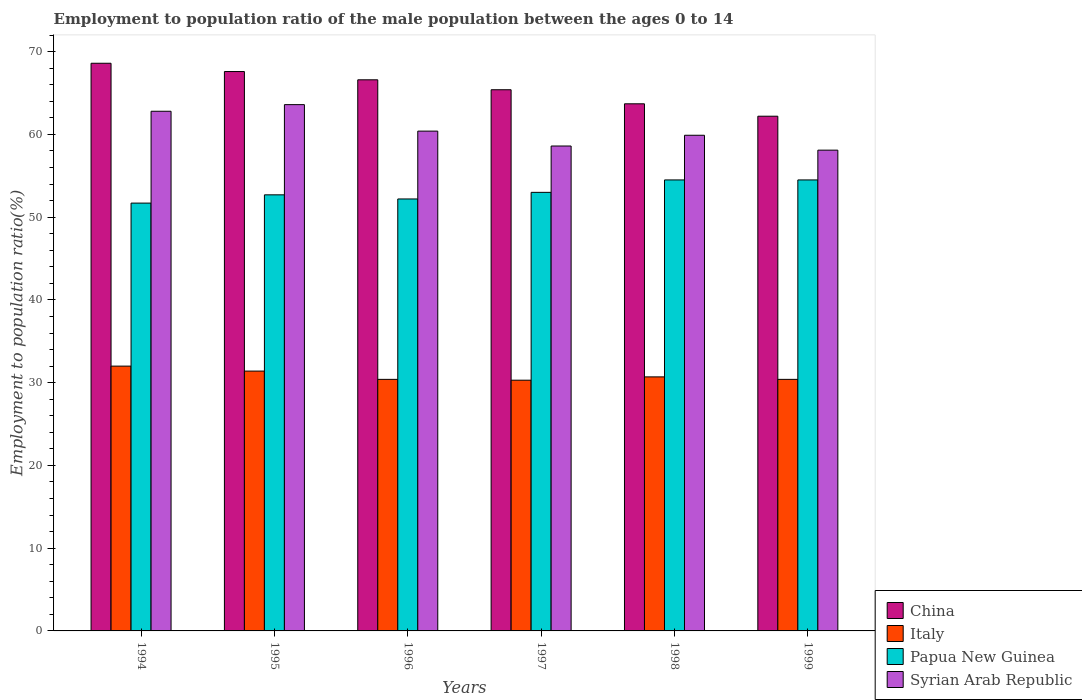How many bars are there on the 5th tick from the right?
Make the answer very short. 4. In how many cases, is the number of bars for a given year not equal to the number of legend labels?
Give a very brief answer. 0. What is the employment to population ratio in Syrian Arab Republic in 1996?
Offer a very short reply. 60.4. Across all years, what is the maximum employment to population ratio in Syrian Arab Republic?
Provide a succinct answer. 63.6. Across all years, what is the minimum employment to population ratio in China?
Keep it short and to the point. 62.2. In which year was the employment to population ratio in Italy maximum?
Provide a succinct answer. 1994. What is the total employment to population ratio in Papua New Guinea in the graph?
Offer a very short reply. 318.6. What is the difference between the employment to population ratio in Italy in 1996 and that in 1997?
Your response must be concise. 0.1. What is the difference between the employment to population ratio in Papua New Guinea in 1996 and the employment to population ratio in Italy in 1994?
Offer a terse response. 20.2. What is the average employment to population ratio in Syrian Arab Republic per year?
Give a very brief answer. 60.57. In the year 1999, what is the difference between the employment to population ratio in Italy and employment to population ratio in Papua New Guinea?
Make the answer very short. -24.1. What is the ratio of the employment to population ratio in Syrian Arab Republic in 1997 to that in 1998?
Offer a terse response. 0.98. What is the difference between the highest and the second highest employment to population ratio in Italy?
Keep it short and to the point. 0.6. What is the difference between the highest and the lowest employment to population ratio in Italy?
Give a very brief answer. 1.7. In how many years, is the employment to population ratio in Papua New Guinea greater than the average employment to population ratio in Papua New Guinea taken over all years?
Your answer should be very brief. 2. Is the sum of the employment to population ratio in Syrian Arab Republic in 1995 and 1997 greater than the maximum employment to population ratio in China across all years?
Keep it short and to the point. Yes. Is it the case that in every year, the sum of the employment to population ratio in Syrian Arab Republic and employment to population ratio in China is greater than the sum of employment to population ratio in Papua New Guinea and employment to population ratio in Italy?
Ensure brevity in your answer.  Yes. Are all the bars in the graph horizontal?
Offer a terse response. No. Are the values on the major ticks of Y-axis written in scientific E-notation?
Provide a succinct answer. No. Does the graph contain any zero values?
Your answer should be very brief. No. How many legend labels are there?
Offer a very short reply. 4. How are the legend labels stacked?
Your answer should be compact. Vertical. What is the title of the graph?
Offer a very short reply. Employment to population ratio of the male population between the ages 0 to 14. Does "Channel Islands" appear as one of the legend labels in the graph?
Provide a succinct answer. No. What is the label or title of the Y-axis?
Your response must be concise. Employment to population ratio(%). What is the Employment to population ratio(%) of China in 1994?
Your answer should be compact. 68.6. What is the Employment to population ratio(%) in Italy in 1994?
Ensure brevity in your answer.  32. What is the Employment to population ratio(%) of Papua New Guinea in 1994?
Offer a terse response. 51.7. What is the Employment to population ratio(%) in Syrian Arab Republic in 1994?
Ensure brevity in your answer.  62.8. What is the Employment to population ratio(%) of China in 1995?
Your answer should be compact. 67.6. What is the Employment to population ratio(%) of Italy in 1995?
Provide a succinct answer. 31.4. What is the Employment to population ratio(%) in Papua New Guinea in 1995?
Keep it short and to the point. 52.7. What is the Employment to population ratio(%) in Syrian Arab Republic in 1995?
Give a very brief answer. 63.6. What is the Employment to population ratio(%) of China in 1996?
Offer a terse response. 66.6. What is the Employment to population ratio(%) in Italy in 1996?
Make the answer very short. 30.4. What is the Employment to population ratio(%) of Papua New Guinea in 1996?
Offer a very short reply. 52.2. What is the Employment to population ratio(%) in Syrian Arab Republic in 1996?
Offer a terse response. 60.4. What is the Employment to population ratio(%) in China in 1997?
Provide a short and direct response. 65.4. What is the Employment to population ratio(%) of Italy in 1997?
Keep it short and to the point. 30.3. What is the Employment to population ratio(%) in Syrian Arab Republic in 1997?
Make the answer very short. 58.6. What is the Employment to population ratio(%) in China in 1998?
Your answer should be very brief. 63.7. What is the Employment to population ratio(%) in Italy in 1998?
Offer a terse response. 30.7. What is the Employment to population ratio(%) in Papua New Guinea in 1998?
Ensure brevity in your answer.  54.5. What is the Employment to population ratio(%) in Syrian Arab Republic in 1998?
Your response must be concise. 59.9. What is the Employment to population ratio(%) in China in 1999?
Provide a short and direct response. 62.2. What is the Employment to population ratio(%) of Italy in 1999?
Your answer should be very brief. 30.4. What is the Employment to population ratio(%) of Papua New Guinea in 1999?
Ensure brevity in your answer.  54.5. What is the Employment to population ratio(%) in Syrian Arab Republic in 1999?
Make the answer very short. 58.1. Across all years, what is the maximum Employment to population ratio(%) of China?
Your answer should be compact. 68.6. Across all years, what is the maximum Employment to population ratio(%) in Papua New Guinea?
Your answer should be compact. 54.5. Across all years, what is the maximum Employment to population ratio(%) of Syrian Arab Republic?
Offer a very short reply. 63.6. Across all years, what is the minimum Employment to population ratio(%) of China?
Ensure brevity in your answer.  62.2. Across all years, what is the minimum Employment to population ratio(%) in Italy?
Your answer should be compact. 30.3. Across all years, what is the minimum Employment to population ratio(%) in Papua New Guinea?
Provide a short and direct response. 51.7. Across all years, what is the minimum Employment to population ratio(%) in Syrian Arab Republic?
Ensure brevity in your answer.  58.1. What is the total Employment to population ratio(%) in China in the graph?
Ensure brevity in your answer.  394.1. What is the total Employment to population ratio(%) in Italy in the graph?
Give a very brief answer. 185.2. What is the total Employment to population ratio(%) in Papua New Guinea in the graph?
Offer a terse response. 318.6. What is the total Employment to population ratio(%) of Syrian Arab Republic in the graph?
Give a very brief answer. 363.4. What is the difference between the Employment to population ratio(%) in Syrian Arab Republic in 1994 and that in 1995?
Your answer should be compact. -0.8. What is the difference between the Employment to population ratio(%) in China in 1994 and that in 1996?
Make the answer very short. 2. What is the difference between the Employment to population ratio(%) of Italy in 1994 and that in 1996?
Give a very brief answer. 1.6. What is the difference between the Employment to population ratio(%) in Syrian Arab Republic in 1994 and that in 1996?
Offer a terse response. 2.4. What is the difference between the Employment to population ratio(%) of China in 1994 and that in 1997?
Keep it short and to the point. 3.2. What is the difference between the Employment to population ratio(%) of Syrian Arab Republic in 1994 and that in 1997?
Your answer should be very brief. 4.2. What is the difference between the Employment to population ratio(%) of China in 1994 and that in 1998?
Your response must be concise. 4.9. What is the difference between the Employment to population ratio(%) in Italy in 1994 and that in 1998?
Make the answer very short. 1.3. What is the difference between the Employment to population ratio(%) of Papua New Guinea in 1994 and that in 1998?
Your answer should be compact. -2.8. What is the difference between the Employment to population ratio(%) of Syrian Arab Republic in 1994 and that in 1998?
Keep it short and to the point. 2.9. What is the difference between the Employment to population ratio(%) in China in 1994 and that in 1999?
Provide a succinct answer. 6.4. What is the difference between the Employment to population ratio(%) in Italy in 1995 and that in 1996?
Your answer should be very brief. 1. What is the difference between the Employment to population ratio(%) in Syrian Arab Republic in 1995 and that in 1996?
Provide a succinct answer. 3.2. What is the difference between the Employment to population ratio(%) of China in 1995 and that in 1997?
Keep it short and to the point. 2.2. What is the difference between the Employment to population ratio(%) in Papua New Guinea in 1995 and that in 1997?
Your response must be concise. -0.3. What is the difference between the Employment to population ratio(%) in Syrian Arab Republic in 1995 and that in 1997?
Provide a succinct answer. 5. What is the difference between the Employment to population ratio(%) in China in 1995 and that in 1998?
Your answer should be very brief. 3.9. What is the difference between the Employment to population ratio(%) in Papua New Guinea in 1995 and that in 1998?
Your answer should be compact. -1.8. What is the difference between the Employment to population ratio(%) of Syrian Arab Republic in 1995 and that in 1998?
Your response must be concise. 3.7. What is the difference between the Employment to population ratio(%) in China in 1995 and that in 1999?
Provide a short and direct response. 5.4. What is the difference between the Employment to population ratio(%) in Syrian Arab Republic in 1995 and that in 1999?
Your answer should be compact. 5.5. What is the difference between the Employment to population ratio(%) in Italy in 1996 and that in 1997?
Provide a short and direct response. 0.1. What is the difference between the Employment to population ratio(%) of Papua New Guinea in 1996 and that in 1998?
Your answer should be compact. -2.3. What is the difference between the Employment to population ratio(%) of China in 1996 and that in 1999?
Provide a short and direct response. 4.4. What is the difference between the Employment to population ratio(%) in Italy in 1996 and that in 1999?
Offer a terse response. 0. What is the difference between the Employment to population ratio(%) in Syrian Arab Republic in 1996 and that in 1999?
Make the answer very short. 2.3. What is the difference between the Employment to population ratio(%) of China in 1997 and that in 1998?
Offer a very short reply. 1.7. What is the difference between the Employment to population ratio(%) of Italy in 1997 and that in 1998?
Offer a very short reply. -0.4. What is the difference between the Employment to population ratio(%) of China in 1997 and that in 1999?
Keep it short and to the point. 3.2. What is the difference between the Employment to population ratio(%) of China in 1998 and that in 1999?
Make the answer very short. 1.5. What is the difference between the Employment to population ratio(%) in Italy in 1998 and that in 1999?
Offer a terse response. 0.3. What is the difference between the Employment to population ratio(%) of Papua New Guinea in 1998 and that in 1999?
Your response must be concise. 0. What is the difference between the Employment to population ratio(%) of Syrian Arab Republic in 1998 and that in 1999?
Your answer should be very brief. 1.8. What is the difference between the Employment to population ratio(%) of China in 1994 and the Employment to population ratio(%) of Italy in 1995?
Offer a terse response. 37.2. What is the difference between the Employment to population ratio(%) of China in 1994 and the Employment to population ratio(%) of Papua New Guinea in 1995?
Your response must be concise. 15.9. What is the difference between the Employment to population ratio(%) in China in 1994 and the Employment to population ratio(%) in Syrian Arab Republic in 1995?
Keep it short and to the point. 5. What is the difference between the Employment to population ratio(%) of Italy in 1994 and the Employment to population ratio(%) of Papua New Guinea in 1995?
Keep it short and to the point. -20.7. What is the difference between the Employment to population ratio(%) in Italy in 1994 and the Employment to population ratio(%) in Syrian Arab Republic in 1995?
Ensure brevity in your answer.  -31.6. What is the difference between the Employment to population ratio(%) in Papua New Guinea in 1994 and the Employment to population ratio(%) in Syrian Arab Republic in 1995?
Your answer should be very brief. -11.9. What is the difference between the Employment to population ratio(%) of China in 1994 and the Employment to population ratio(%) of Italy in 1996?
Make the answer very short. 38.2. What is the difference between the Employment to population ratio(%) in China in 1994 and the Employment to population ratio(%) in Papua New Guinea in 1996?
Your answer should be very brief. 16.4. What is the difference between the Employment to population ratio(%) in China in 1994 and the Employment to population ratio(%) in Syrian Arab Republic in 1996?
Your answer should be compact. 8.2. What is the difference between the Employment to population ratio(%) of Italy in 1994 and the Employment to population ratio(%) of Papua New Guinea in 1996?
Provide a succinct answer. -20.2. What is the difference between the Employment to population ratio(%) in Italy in 1994 and the Employment to population ratio(%) in Syrian Arab Republic in 1996?
Ensure brevity in your answer.  -28.4. What is the difference between the Employment to population ratio(%) in Papua New Guinea in 1994 and the Employment to population ratio(%) in Syrian Arab Republic in 1996?
Offer a very short reply. -8.7. What is the difference between the Employment to population ratio(%) of China in 1994 and the Employment to population ratio(%) of Italy in 1997?
Your response must be concise. 38.3. What is the difference between the Employment to population ratio(%) of China in 1994 and the Employment to population ratio(%) of Syrian Arab Republic in 1997?
Your answer should be compact. 10. What is the difference between the Employment to population ratio(%) of Italy in 1994 and the Employment to population ratio(%) of Papua New Guinea in 1997?
Your answer should be compact. -21. What is the difference between the Employment to population ratio(%) of Italy in 1994 and the Employment to population ratio(%) of Syrian Arab Republic in 1997?
Ensure brevity in your answer.  -26.6. What is the difference between the Employment to population ratio(%) in China in 1994 and the Employment to population ratio(%) in Italy in 1998?
Your answer should be very brief. 37.9. What is the difference between the Employment to population ratio(%) of Italy in 1994 and the Employment to population ratio(%) of Papua New Guinea in 1998?
Provide a succinct answer. -22.5. What is the difference between the Employment to population ratio(%) in Italy in 1994 and the Employment to population ratio(%) in Syrian Arab Republic in 1998?
Offer a very short reply. -27.9. What is the difference between the Employment to population ratio(%) of Papua New Guinea in 1994 and the Employment to population ratio(%) of Syrian Arab Republic in 1998?
Give a very brief answer. -8.2. What is the difference between the Employment to population ratio(%) in China in 1994 and the Employment to population ratio(%) in Italy in 1999?
Your response must be concise. 38.2. What is the difference between the Employment to population ratio(%) of China in 1994 and the Employment to population ratio(%) of Syrian Arab Republic in 1999?
Give a very brief answer. 10.5. What is the difference between the Employment to population ratio(%) in Italy in 1994 and the Employment to population ratio(%) in Papua New Guinea in 1999?
Ensure brevity in your answer.  -22.5. What is the difference between the Employment to population ratio(%) in Italy in 1994 and the Employment to population ratio(%) in Syrian Arab Republic in 1999?
Give a very brief answer. -26.1. What is the difference between the Employment to population ratio(%) of Papua New Guinea in 1994 and the Employment to population ratio(%) of Syrian Arab Republic in 1999?
Offer a terse response. -6.4. What is the difference between the Employment to population ratio(%) in China in 1995 and the Employment to population ratio(%) in Italy in 1996?
Make the answer very short. 37.2. What is the difference between the Employment to population ratio(%) of Italy in 1995 and the Employment to population ratio(%) of Papua New Guinea in 1996?
Your response must be concise. -20.8. What is the difference between the Employment to population ratio(%) of Papua New Guinea in 1995 and the Employment to population ratio(%) of Syrian Arab Republic in 1996?
Make the answer very short. -7.7. What is the difference between the Employment to population ratio(%) of China in 1995 and the Employment to population ratio(%) of Italy in 1997?
Provide a succinct answer. 37.3. What is the difference between the Employment to population ratio(%) of China in 1995 and the Employment to population ratio(%) of Papua New Guinea in 1997?
Ensure brevity in your answer.  14.6. What is the difference between the Employment to population ratio(%) in China in 1995 and the Employment to population ratio(%) in Syrian Arab Republic in 1997?
Provide a succinct answer. 9. What is the difference between the Employment to population ratio(%) in Italy in 1995 and the Employment to population ratio(%) in Papua New Guinea in 1997?
Provide a succinct answer. -21.6. What is the difference between the Employment to population ratio(%) in Italy in 1995 and the Employment to population ratio(%) in Syrian Arab Republic in 1997?
Provide a short and direct response. -27.2. What is the difference between the Employment to population ratio(%) in China in 1995 and the Employment to population ratio(%) in Italy in 1998?
Keep it short and to the point. 36.9. What is the difference between the Employment to population ratio(%) in Italy in 1995 and the Employment to population ratio(%) in Papua New Guinea in 1998?
Make the answer very short. -23.1. What is the difference between the Employment to population ratio(%) of Italy in 1995 and the Employment to population ratio(%) of Syrian Arab Republic in 1998?
Offer a very short reply. -28.5. What is the difference between the Employment to population ratio(%) of China in 1995 and the Employment to population ratio(%) of Italy in 1999?
Keep it short and to the point. 37.2. What is the difference between the Employment to population ratio(%) of China in 1995 and the Employment to population ratio(%) of Papua New Guinea in 1999?
Your response must be concise. 13.1. What is the difference between the Employment to population ratio(%) of Italy in 1995 and the Employment to population ratio(%) of Papua New Guinea in 1999?
Provide a succinct answer. -23.1. What is the difference between the Employment to population ratio(%) in Italy in 1995 and the Employment to population ratio(%) in Syrian Arab Republic in 1999?
Give a very brief answer. -26.7. What is the difference between the Employment to population ratio(%) of China in 1996 and the Employment to population ratio(%) of Italy in 1997?
Give a very brief answer. 36.3. What is the difference between the Employment to population ratio(%) in China in 1996 and the Employment to population ratio(%) in Papua New Guinea in 1997?
Ensure brevity in your answer.  13.6. What is the difference between the Employment to population ratio(%) of China in 1996 and the Employment to population ratio(%) of Syrian Arab Republic in 1997?
Keep it short and to the point. 8. What is the difference between the Employment to population ratio(%) of Italy in 1996 and the Employment to population ratio(%) of Papua New Guinea in 1997?
Provide a succinct answer. -22.6. What is the difference between the Employment to population ratio(%) of Italy in 1996 and the Employment to population ratio(%) of Syrian Arab Republic in 1997?
Offer a terse response. -28.2. What is the difference between the Employment to population ratio(%) of Papua New Guinea in 1996 and the Employment to population ratio(%) of Syrian Arab Republic in 1997?
Your answer should be very brief. -6.4. What is the difference between the Employment to population ratio(%) of China in 1996 and the Employment to population ratio(%) of Italy in 1998?
Your response must be concise. 35.9. What is the difference between the Employment to population ratio(%) of China in 1996 and the Employment to population ratio(%) of Papua New Guinea in 1998?
Your answer should be compact. 12.1. What is the difference between the Employment to population ratio(%) of Italy in 1996 and the Employment to population ratio(%) of Papua New Guinea in 1998?
Your answer should be very brief. -24.1. What is the difference between the Employment to population ratio(%) in Italy in 1996 and the Employment to population ratio(%) in Syrian Arab Republic in 1998?
Your answer should be compact. -29.5. What is the difference between the Employment to population ratio(%) of China in 1996 and the Employment to population ratio(%) of Italy in 1999?
Your answer should be very brief. 36.2. What is the difference between the Employment to population ratio(%) in China in 1996 and the Employment to population ratio(%) in Papua New Guinea in 1999?
Ensure brevity in your answer.  12.1. What is the difference between the Employment to population ratio(%) in China in 1996 and the Employment to population ratio(%) in Syrian Arab Republic in 1999?
Offer a terse response. 8.5. What is the difference between the Employment to population ratio(%) of Italy in 1996 and the Employment to population ratio(%) of Papua New Guinea in 1999?
Offer a very short reply. -24.1. What is the difference between the Employment to population ratio(%) in Italy in 1996 and the Employment to population ratio(%) in Syrian Arab Republic in 1999?
Your answer should be very brief. -27.7. What is the difference between the Employment to population ratio(%) of China in 1997 and the Employment to population ratio(%) of Italy in 1998?
Provide a succinct answer. 34.7. What is the difference between the Employment to population ratio(%) of China in 1997 and the Employment to population ratio(%) of Syrian Arab Republic in 1998?
Make the answer very short. 5.5. What is the difference between the Employment to population ratio(%) of Italy in 1997 and the Employment to population ratio(%) of Papua New Guinea in 1998?
Provide a short and direct response. -24.2. What is the difference between the Employment to population ratio(%) in Italy in 1997 and the Employment to population ratio(%) in Syrian Arab Republic in 1998?
Ensure brevity in your answer.  -29.6. What is the difference between the Employment to population ratio(%) in Papua New Guinea in 1997 and the Employment to population ratio(%) in Syrian Arab Republic in 1998?
Provide a succinct answer. -6.9. What is the difference between the Employment to population ratio(%) of China in 1997 and the Employment to population ratio(%) of Syrian Arab Republic in 1999?
Provide a short and direct response. 7.3. What is the difference between the Employment to population ratio(%) in Italy in 1997 and the Employment to population ratio(%) in Papua New Guinea in 1999?
Make the answer very short. -24.2. What is the difference between the Employment to population ratio(%) of Italy in 1997 and the Employment to population ratio(%) of Syrian Arab Republic in 1999?
Your response must be concise. -27.8. What is the difference between the Employment to population ratio(%) of Papua New Guinea in 1997 and the Employment to population ratio(%) of Syrian Arab Republic in 1999?
Your answer should be compact. -5.1. What is the difference between the Employment to population ratio(%) in China in 1998 and the Employment to population ratio(%) in Italy in 1999?
Your response must be concise. 33.3. What is the difference between the Employment to population ratio(%) in China in 1998 and the Employment to population ratio(%) in Papua New Guinea in 1999?
Your answer should be compact. 9.2. What is the difference between the Employment to population ratio(%) of Italy in 1998 and the Employment to population ratio(%) of Papua New Guinea in 1999?
Provide a short and direct response. -23.8. What is the difference between the Employment to population ratio(%) of Italy in 1998 and the Employment to population ratio(%) of Syrian Arab Republic in 1999?
Give a very brief answer. -27.4. What is the difference between the Employment to population ratio(%) in Papua New Guinea in 1998 and the Employment to population ratio(%) in Syrian Arab Republic in 1999?
Your answer should be very brief. -3.6. What is the average Employment to population ratio(%) in China per year?
Ensure brevity in your answer.  65.68. What is the average Employment to population ratio(%) of Italy per year?
Give a very brief answer. 30.87. What is the average Employment to population ratio(%) in Papua New Guinea per year?
Provide a short and direct response. 53.1. What is the average Employment to population ratio(%) in Syrian Arab Republic per year?
Your answer should be compact. 60.57. In the year 1994, what is the difference between the Employment to population ratio(%) of China and Employment to population ratio(%) of Italy?
Offer a terse response. 36.6. In the year 1994, what is the difference between the Employment to population ratio(%) of China and Employment to population ratio(%) of Papua New Guinea?
Your response must be concise. 16.9. In the year 1994, what is the difference between the Employment to population ratio(%) of Italy and Employment to population ratio(%) of Papua New Guinea?
Make the answer very short. -19.7. In the year 1994, what is the difference between the Employment to population ratio(%) of Italy and Employment to population ratio(%) of Syrian Arab Republic?
Ensure brevity in your answer.  -30.8. In the year 1994, what is the difference between the Employment to population ratio(%) of Papua New Guinea and Employment to population ratio(%) of Syrian Arab Republic?
Your answer should be compact. -11.1. In the year 1995, what is the difference between the Employment to population ratio(%) in China and Employment to population ratio(%) in Italy?
Your response must be concise. 36.2. In the year 1995, what is the difference between the Employment to population ratio(%) in Italy and Employment to population ratio(%) in Papua New Guinea?
Provide a succinct answer. -21.3. In the year 1995, what is the difference between the Employment to population ratio(%) of Italy and Employment to population ratio(%) of Syrian Arab Republic?
Provide a succinct answer. -32.2. In the year 1995, what is the difference between the Employment to population ratio(%) in Papua New Guinea and Employment to population ratio(%) in Syrian Arab Republic?
Offer a very short reply. -10.9. In the year 1996, what is the difference between the Employment to population ratio(%) of China and Employment to population ratio(%) of Italy?
Your answer should be compact. 36.2. In the year 1996, what is the difference between the Employment to population ratio(%) of China and Employment to population ratio(%) of Syrian Arab Republic?
Your response must be concise. 6.2. In the year 1996, what is the difference between the Employment to population ratio(%) in Italy and Employment to population ratio(%) in Papua New Guinea?
Offer a terse response. -21.8. In the year 1996, what is the difference between the Employment to population ratio(%) of Italy and Employment to population ratio(%) of Syrian Arab Republic?
Provide a short and direct response. -30. In the year 1997, what is the difference between the Employment to population ratio(%) in China and Employment to population ratio(%) in Italy?
Your answer should be very brief. 35.1. In the year 1997, what is the difference between the Employment to population ratio(%) in Italy and Employment to population ratio(%) in Papua New Guinea?
Offer a terse response. -22.7. In the year 1997, what is the difference between the Employment to population ratio(%) in Italy and Employment to population ratio(%) in Syrian Arab Republic?
Ensure brevity in your answer.  -28.3. In the year 1998, what is the difference between the Employment to population ratio(%) in China and Employment to population ratio(%) in Italy?
Your answer should be very brief. 33. In the year 1998, what is the difference between the Employment to population ratio(%) of China and Employment to population ratio(%) of Syrian Arab Republic?
Offer a terse response. 3.8. In the year 1998, what is the difference between the Employment to population ratio(%) of Italy and Employment to population ratio(%) of Papua New Guinea?
Your response must be concise. -23.8. In the year 1998, what is the difference between the Employment to population ratio(%) in Italy and Employment to population ratio(%) in Syrian Arab Republic?
Your response must be concise. -29.2. In the year 1999, what is the difference between the Employment to population ratio(%) in China and Employment to population ratio(%) in Italy?
Offer a terse response. 31.8. In the year 1999, what is the difference between the Employment to population ratio(%) in China and Employment to population ratio(%) in Papua New Guinea?
Make the answer very short. 7.7. In the year 1999, what is the difference between the Employment to population ratio(%) of Italy and Employment to population ratio(%) of Papua New Guinea?
Ensure brevity in your answer.  -24.1. In the year 1999, what is the difference between the Employment to population ratio(%) in Italy and Employment to population ratio(%) in Syrian Arab Republic?
Keep it short and to the point. -27.7. What is the ratio of the Employment to population ratio(%) in China in 1994 to that in 1995?
Provide a succinct answer. 1.01. What is the ratio of the Employment to population ratio(%) in Italy in 1994 to that in 1995?
Make the answer very short. 1.02. What is the ratio of the Employment to population ratio(%) in Papua New Guinea in 1994 to that in 1995?
Offer a very short reply. 0.98. What is the ratio of the Employment to population ratio(%) in Syrian Arab Republic in 1994 to that in 1995?
Provide a short and direct response. 0.99. What is the ratio of the Employment to population ratio(%) in Italy in 1994 to that in 1996?
Your response must be concise. 1.05. What is the ratio of the Employment to population ratio(%) in Syrian Arab Republic in 1994 to that in 1996?
Offer a terse response. 1.04. What is the ratio of the Employment to population ratio(%) of China in 1994 to that in 1997?
Your response must be concise. 1.05. What is the ratio of the Employment to population ratio(%) of Italy in 1994 to that in 1997?
Ensure brevity in your answer.  1.06. What is the ratio of the Employment to population ratio(%) of Papua New Guinea in 1994 to that in 1997?
Your answer should be compact. 0.98. What is the ratio of the Employment to population ratio(%) in Syrian Arab Republic in 1994 to that in 1997?
Make the answer very short. 1.07. What is the ratio of the Employment to population ratio(%) of China in 1994 to that in 1998?
Your answer should be compact. 1.08. What is the ratio of the Employment to population ratio(%) of Italy in 1994 to that in 1998?
Offer a very short reply. 1.04. What is the ratio of the Employment to population ratio(%) of Papua New Guinea in 1994 to that in 1998?
Offer a very short reply. 0.95. What is the ratio of the Employment to population ratio(%) of Syrian Arab Republic in 1994 to that in 1998?
Your response must be concise. 1.05. What is the ratio of the Employment to population ratio(%) of China in 1994 to that in 1999?
Your response must be concise. 1.1. What is the ratio of the Employment to population ratio(%) of Italy in 1994 to that in 1999?
Your answer should be compact. 1.05. What is the ratio of the Employment to population ratio(%) of Papua New Guinea in 1994 to that in 1999?
Provide a short and direct response. 0.95. What is the ratio of the Employment to population ratio(%) of Syrian Arab Republic in 1994 to that in 1999?
Your answer should be very brief. 1.08. What is the ratio of the Employment to population ratio(%) in Italy in 1995 to that in 1996?
Provide a short and direct response. 1.03. What is the ratio of the Employment to population ratio(%) in Papua New Guinea in 1995 to that in 1996?
Your answer should be compact. 1.01. What is the ratio of the Employment to population ratio(%) of Syrian Arab Republic in 1995 to that in 1996?
Give a very brief answer. 1.05. What is the ratio of the Employment to population ratio(%) in China in 1995 to that in 1997?
Keep it short and to the point. 1.03. What is the ratio of the Employment to population ratio(%) in Italy in 1995 to that in 1997?
Offer a terse response. 1.04. What is the ratio of the Employment to population ratio(%) of Papua New Guinea in 1995 to that in 1997?
Your answer should be very brief. 0.99. What is the ratio of the Employment to population ratio(%) of Syrian Arab Republic in 1995 to that in 1997?
Your answer should be compact. 1.09. What is the ratio of the Employment to population ratio(%) of China in 1995 to that in 1998?
Ensure brevity in your answer.  1.06. What is the ratio of the Employment to population ratio(%) of Italy in 1995 to that in 1998?
Your response must be concise. 1.02. What is the ratio of the Employment to population ratio(%) of Syrian Arab Republic in 1995 to that in 1998?
Your response must be concise. 1.06. What is the ratio of the Employment to population ratio(%) in China in 1995 to that in 1999?
Ensure brevity in your answer.  1.09. What is the ratio of the Employment to population ratio(%) in Italy in 1995 to that in 1999?
Give a very brief answer. 1.03. What is the ratio of the Employment to population ratio(%) of Papua New Guinea in 1995 to that in 1999?
Offer a very short reply. 0.97. What is the ratio of the Employment to population ratio(%) in Syrian Arab Republic in 1995 to that in 1999?
Give a very brief answer. 1.09. What is the ratio of the Employment to population ratio(%) of China in 1996 to that in 1997?
Your answer should be very brief. 1.02. What is the ratio of the Employment to population ratio(%) in Italy in 1996 to that in 1997?
Offer a terse response. 1. What is the ratio of the Employment to population ratio(%) of Papua New Guinea in 1996 to that in 1997?
Ensure brevity in your answer.  0.98. What is the ratio of the Employment to population ratio(%) in Syrian Arab Republic in 1996 to that in 1997?
Your answer should be very brief. 1.03. What is the ratio of the Employment to population ratio(%) in China in 1996 to that in 1998?
Your answer should be compact. 1.05. What is the ratio of the Employment to population ratio(%) in Italy in 1996 to that in 1998?
Ensure brevity in your answer.  0.99. What is the ratio of the Employment to population ratio(%) of Papua New Guinea in 1996 to that in 1998?
Provide a short and direct response. 0.96. What is the ratio of the Employment to population ratio(%) of Syrian Arab Republic in 1996 to that in 1998?
Your response must be concise. 1.01. What is the ratio of the Employment to population ratio(%) in China in 1996 to that in 1999?
Offer a terse response. 1.07. What is the ratio of the Employment to population ratio(%) of Papua New Guinea in 1996 to that in 1999?
Offer a terse response. 0.96. What is the ratio of the Employment to population ratio(%) of Syrian Arab Republic in 1996 to that in 1999?
Your answer should be compact. 1.04. What is the ratio of the Employment to population ratio(%) in China in 1997 to that in 1998?
Your response must be concise. 1.03. What is the ratio of the Employment to population ratio(%) of Italy in 1997 to that in 1998?
Offer a very short reply. 0.99. What is the ratio of the Employment to population ratio(%) in Papua New Guinea in 1997 to that in 1998?
Provide a succinct answer. 0.97. What is the ratio of the Employment to population ratio(%) of Syrian Arab Republic in 1997 to that in 1998?
Offer a very short reply. 0.98. What is the ratio of the Employment to population ratio(%) in China in 1997 to that in 1999?
Give a very brief answer. 1.05. What is the ratio of the Employment to population ratio(%) in Papua New Guinea in 1997 to that in 1999?
Offer a very short reply. 0.97. What is the ratio of the Employment to population ratio(%) in Syrian Arab Republic in 1997 to that in 1999?
Provide a succinct answer. 1.01. What is the ratio of the Employment to population ratio(%) in China in 1998 to that in 1999?
Your answer should be very brief. 1.02. What is the ratio of the Employment to population ratio(%) in Italy in 1998 to that in 1999?
Make the answer very short. 1.01. What is the ratio of the Employment to population ratio(%) of Papua New Guinea in 1998 to that in 1999?
Make the answer very short. 1. What is the ratio of the Employment to population ratio(%) in Syrian Arab Republic in 1998 to that in 1999?
Offer a terse response. 1.03. What is the difference between the highest and the second highest Employment to population ratio(%) in China?
Your response must be concise. 1. What is the difference between the highest and the second highest Employment to population ratio(%) in Italy?
Offer a terse response. 0.6. What is the difference between the highest and the lowest Employment to population ratio(%) of China?
Ensure brevity in your answer.  6.4. What is the difference between the highest and the lowest Employment to population ratio(%) of Syrian Arab Republic?
Your response must be concise. 5.5. 